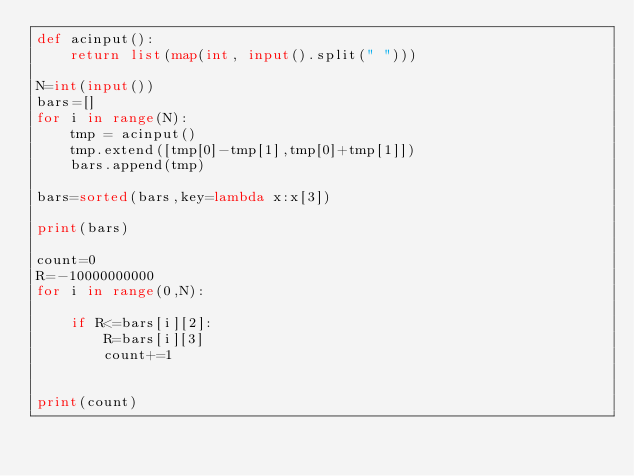Convert code to text. <code><loc_0><loc_0><loc_500><loc_500><_Python_>def acinput():
    return list(map(int, input().split(" ")))

N=int(input())
bars=[]
for i in range(N):
    tmp = acinput()
    tmp.extend([tmp[0]-tmp[1],tmp[0]+tmp[1]])
    bars.append(tmp)

bars=sorted(bars,key=lambda x:x[3])

print(bars)

count=0
R=-10000000000
for i in range(0,N):

    if R<=bars[i][2]:
        R=bars[i][3]
        count+=1


print(count)
</code> 